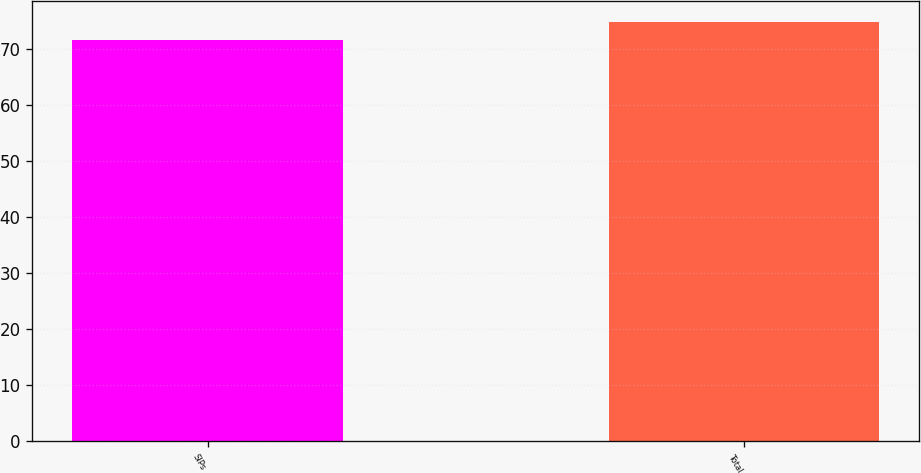<chart> <loc_0><loc_0><loc_500><loc_500><bar_chart><fcel>SIPs<fcel>Total<nl><fcel>71.7<fcel>74.9<nl></chart> 